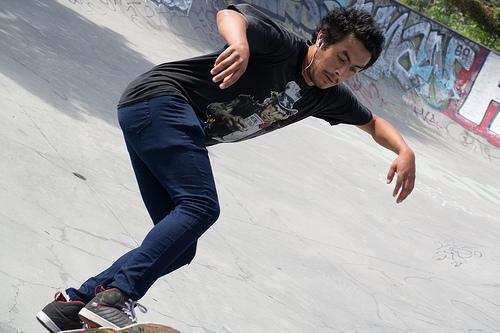How many people are skateboarding?
Give a very brief answer. 1. 